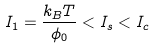Convert formula to latex. <formula><loc_0><loc_0><loc_500><loc_500>I _ { 1 } = \frac { k _ { B } T } { \phi _ { 0 } } < I _ { s } < I _ { c }</formula> 